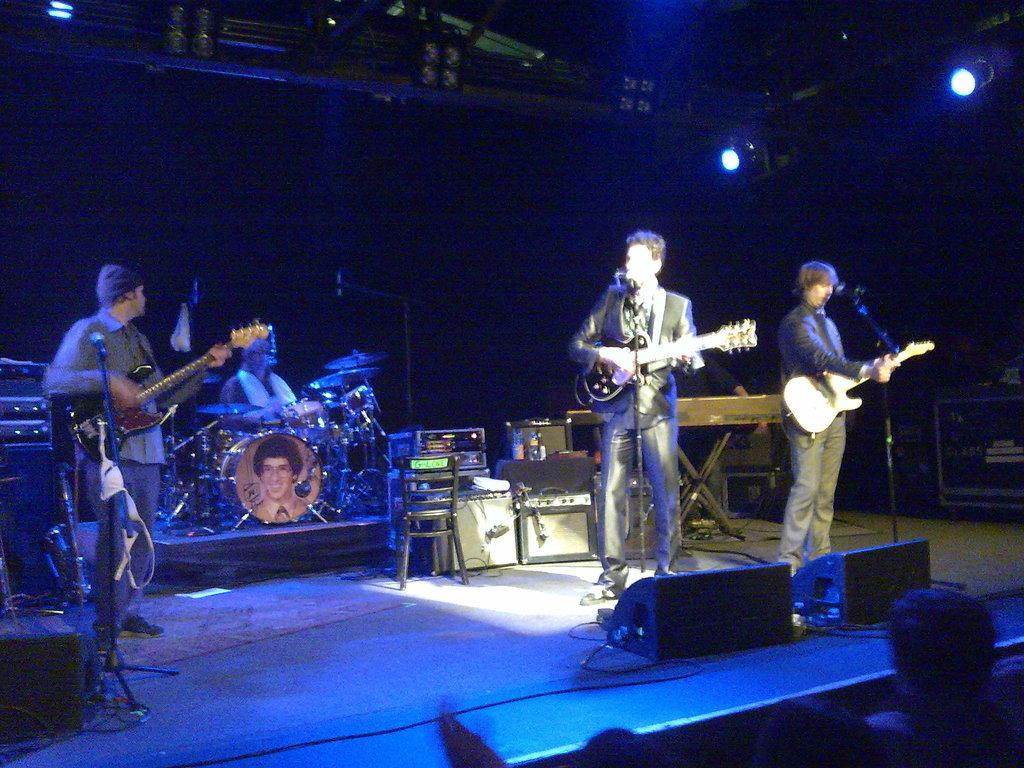How many people are in the image? There are three people in the image. Where are the people located in the image? The people are standing on a stage. What are the people holding in the image? Each person is holding a guitar. What are the people doing with the microphones in the image? The people are singing into microphones. How many feet are visible in the image? The provided facts do not mention any feet, so it is impossible to determine the number of feet visible in the image. 